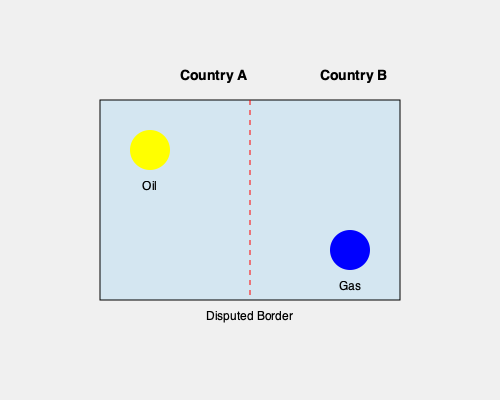Based on the map of natural resources in a disputed territory between Country A and Country B, what potential challenge might arise for an international mediator attempting to negotiate a resource-sharing agreement? To answer this question, we need to analyze the map and consider the implications of resource distribution in the context of a territorial dispute:

1. Resource distribution:
   - The map shows two key natural resources: oil (yellow circle) and gas (blue circle).
   - Oil is located in the western part, primarily within Country A's claimed territory.
   - Gas is located in the eastern part, primarily within Country B's claimed territory.

2. Territorial dispute:
   - The red dashed line represents a disputed border between Country A and Country B.
   - This indicates that both countries claim sovereignty over parts of the territory.

3. Resource access:
   - The location of resources relative to the disputed border creates an imbalance in resource access.
   - Country A has easier access to oil reserves.
   - Country B has easier access to gas reserves.

4. Negotiation challenges:
   - Both countries likely want access to both resources for economic benefits.
   - The uneven distribution may lead to competing claims and reluctance to compromise.
   - Country A might insist on maintaining control over oil-rich areas.
   - Country B might demand access to oil reserves in addition to its gas resources.

5. Potential mediator's challenge:
   - The main challenge for an international mediator would be to propose a fair and equitable solution that addresses the imbalanced resource distribution while satisfying both countries' interests.
   - This may involve complex negotiations on resource-sharing agreements, joint exploration rights, or economic compensation mechanisms.

Given these factors, the primary challenge for an international mediator would be to balance the competing interests of both countries while ensuring equitable access to the unevenly distributed natural resources.
Answer: Balancing equitable resource access amid uneven distribution 